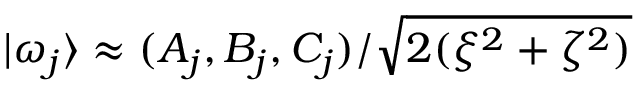<formula> <loc_0><loc_0><loc_500><loc_500>| \omega _ { j } \rangle \approx ( A _ { j } , B _ { j } , C _ { j } ) / \sqrt { 2 ( \xi ^ { 2 } + \zeta ^ { 2 } ) }</formula> 